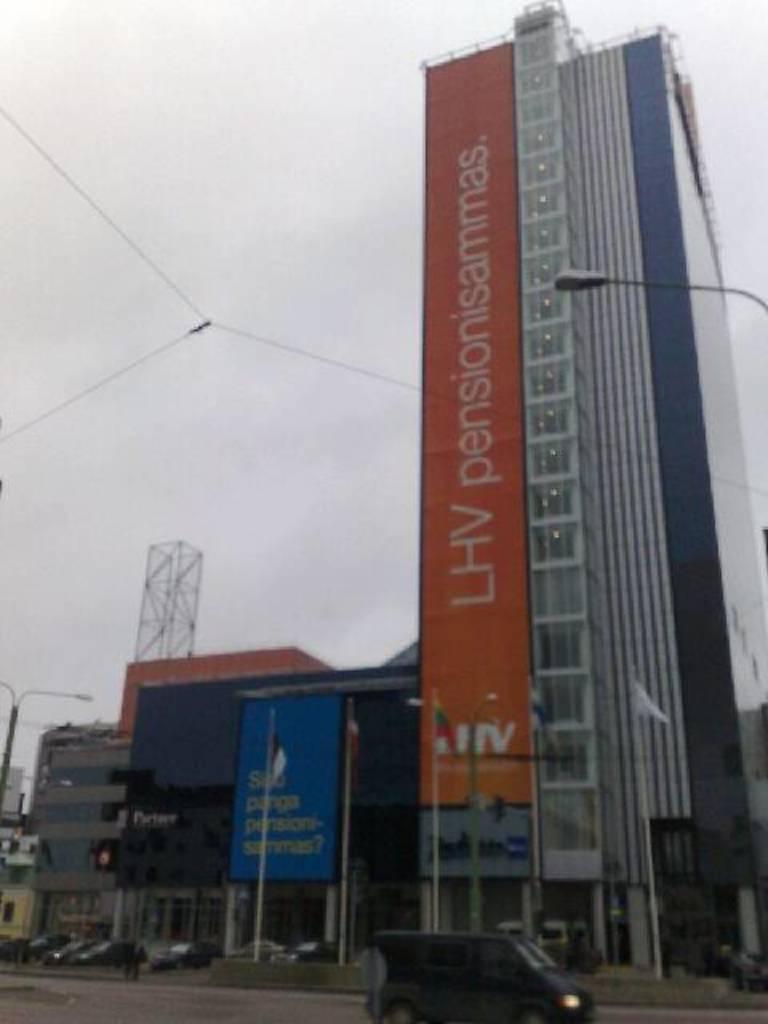Could you give a brief overview of what you see in this image? In front of the image there are vehicles. There is a hoarding with some text on it. There are flags, light poles, buildings. At the top of the image there is sky. 